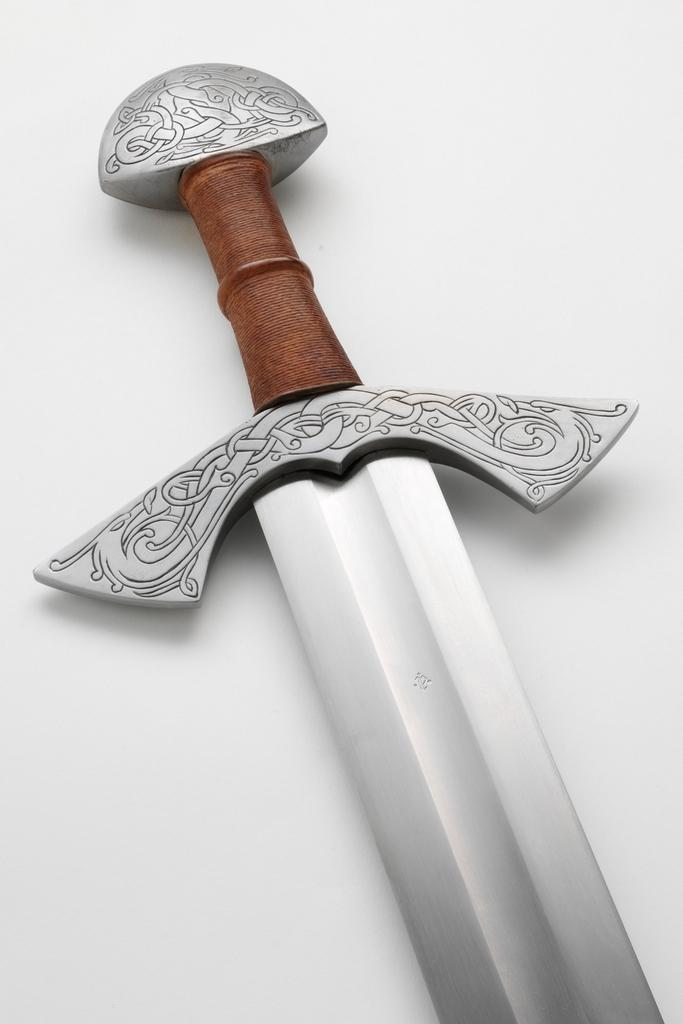What is present on the image? There is a word in the image. What is the color of the word? The word is in silver color. What is the background of the word? The word is placed on a white surface. What time of day is depicted in the image? There is no indication of time of day in the image, as it only features a silver word on a white surface. 